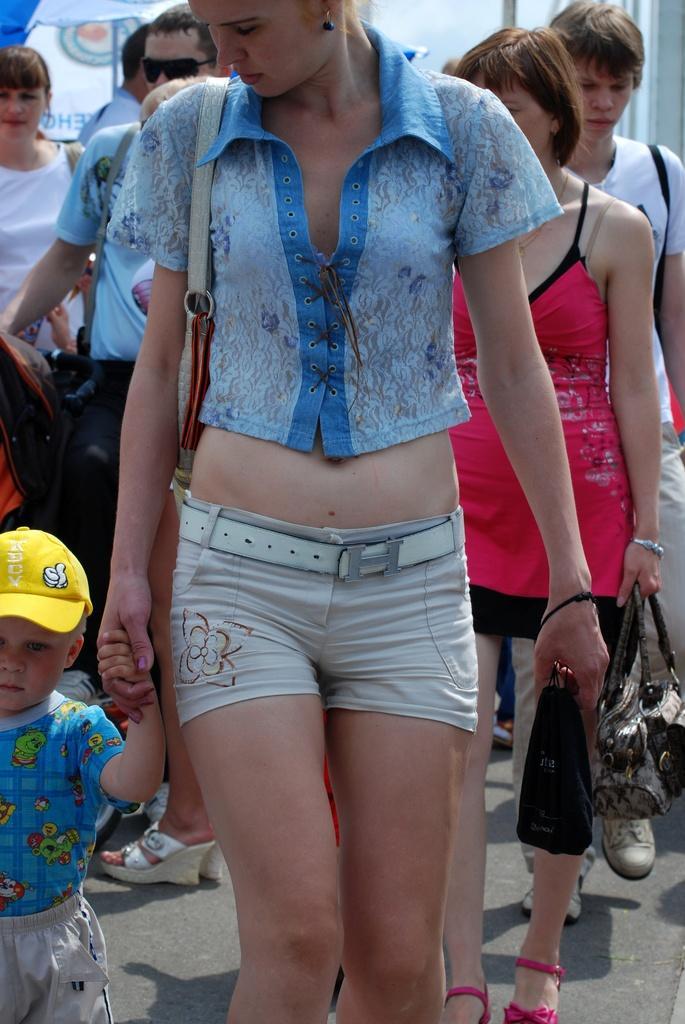Please provide a concise description of this image. In this image I can see people among them this woman is holding an object and a child's hand. 